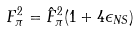Convert formula to latex. <formula><loc_0><loc_0><loc_500><loc_500>F ^ { 2 } _ { \pi } = \hat { F } ^ { 2 } _ { \pi } ( 1 + 4 \epsilon _ { N S } )</formula> 